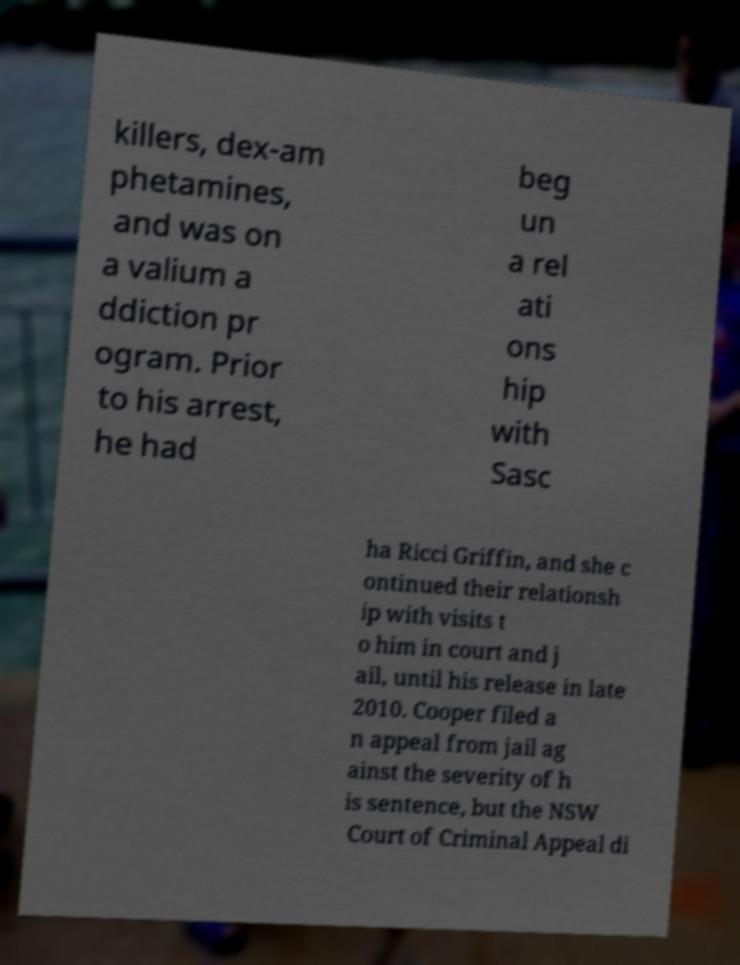Please identify and transcribe the text found in this image. killers, dex-am phetamines, and was on a valium a ddiction pr ogram. Prior to his arrest, he had beg un a rel ati ons hip with Sasc ha Ricci Griffin, and she c ontinued their relationsh ip with visits t o him in court and j ail, until his release in late 2010. Cooper filed a n appeal from jail ag ainst the severity of h is sentence, but the NSW Court of Criminal Appeal di 